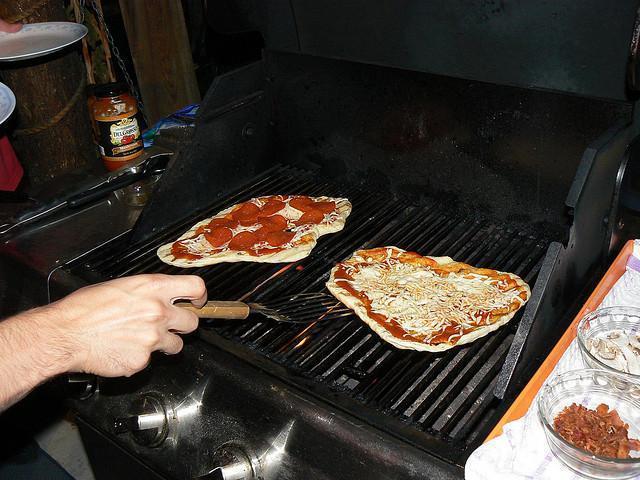How many pizzas can be seen?
Give a very brief answer. 2. How many bowls are there?
Give a very brief answer. 2. 